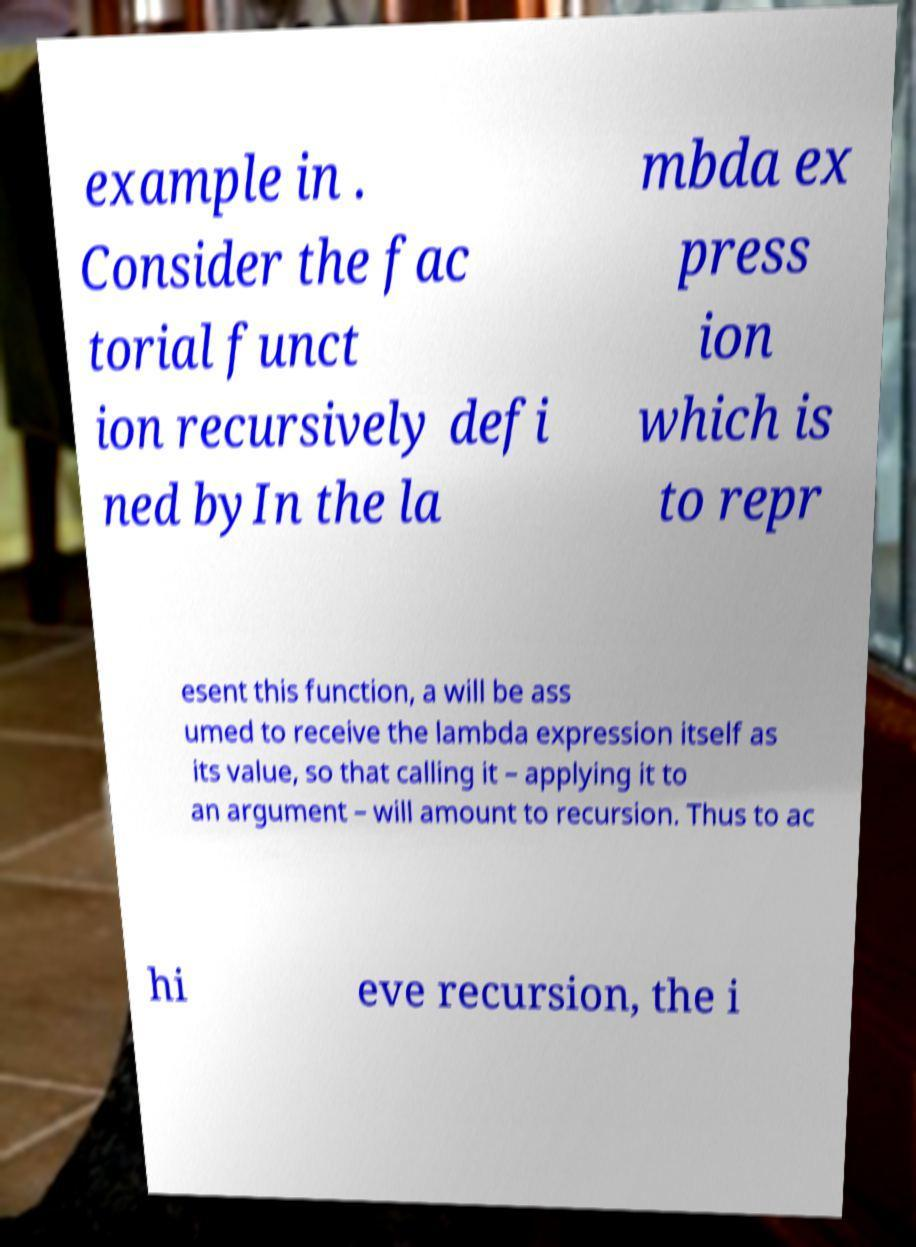Please read and relay the text visible in this image. What does it say? example in . Consider the fac torial funct ion recursively defi ned byIn the la mbda ex press ion which is to repr esent this function, a will be ass umed to receive the lambda expression itself as its value, so that calling it – applying it to an argument – will amount to recursion. Thus to ac hi eve recursion, the i 